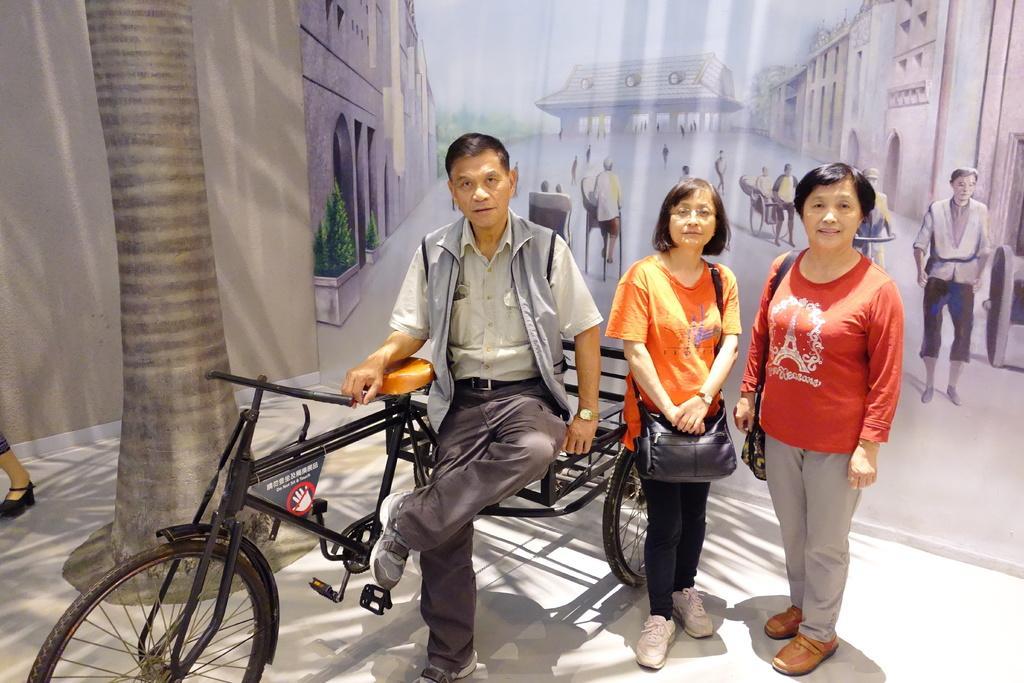Please provide a concise description of this image. In the center of the image a man is sitting on a vehicle. On the right side of the image two ladies are standing and wearing bag. On the left side of the image a tree and a person leg, wall are there. At the bottom of the image floor is there. In the background of the image a poster to wall is there. 